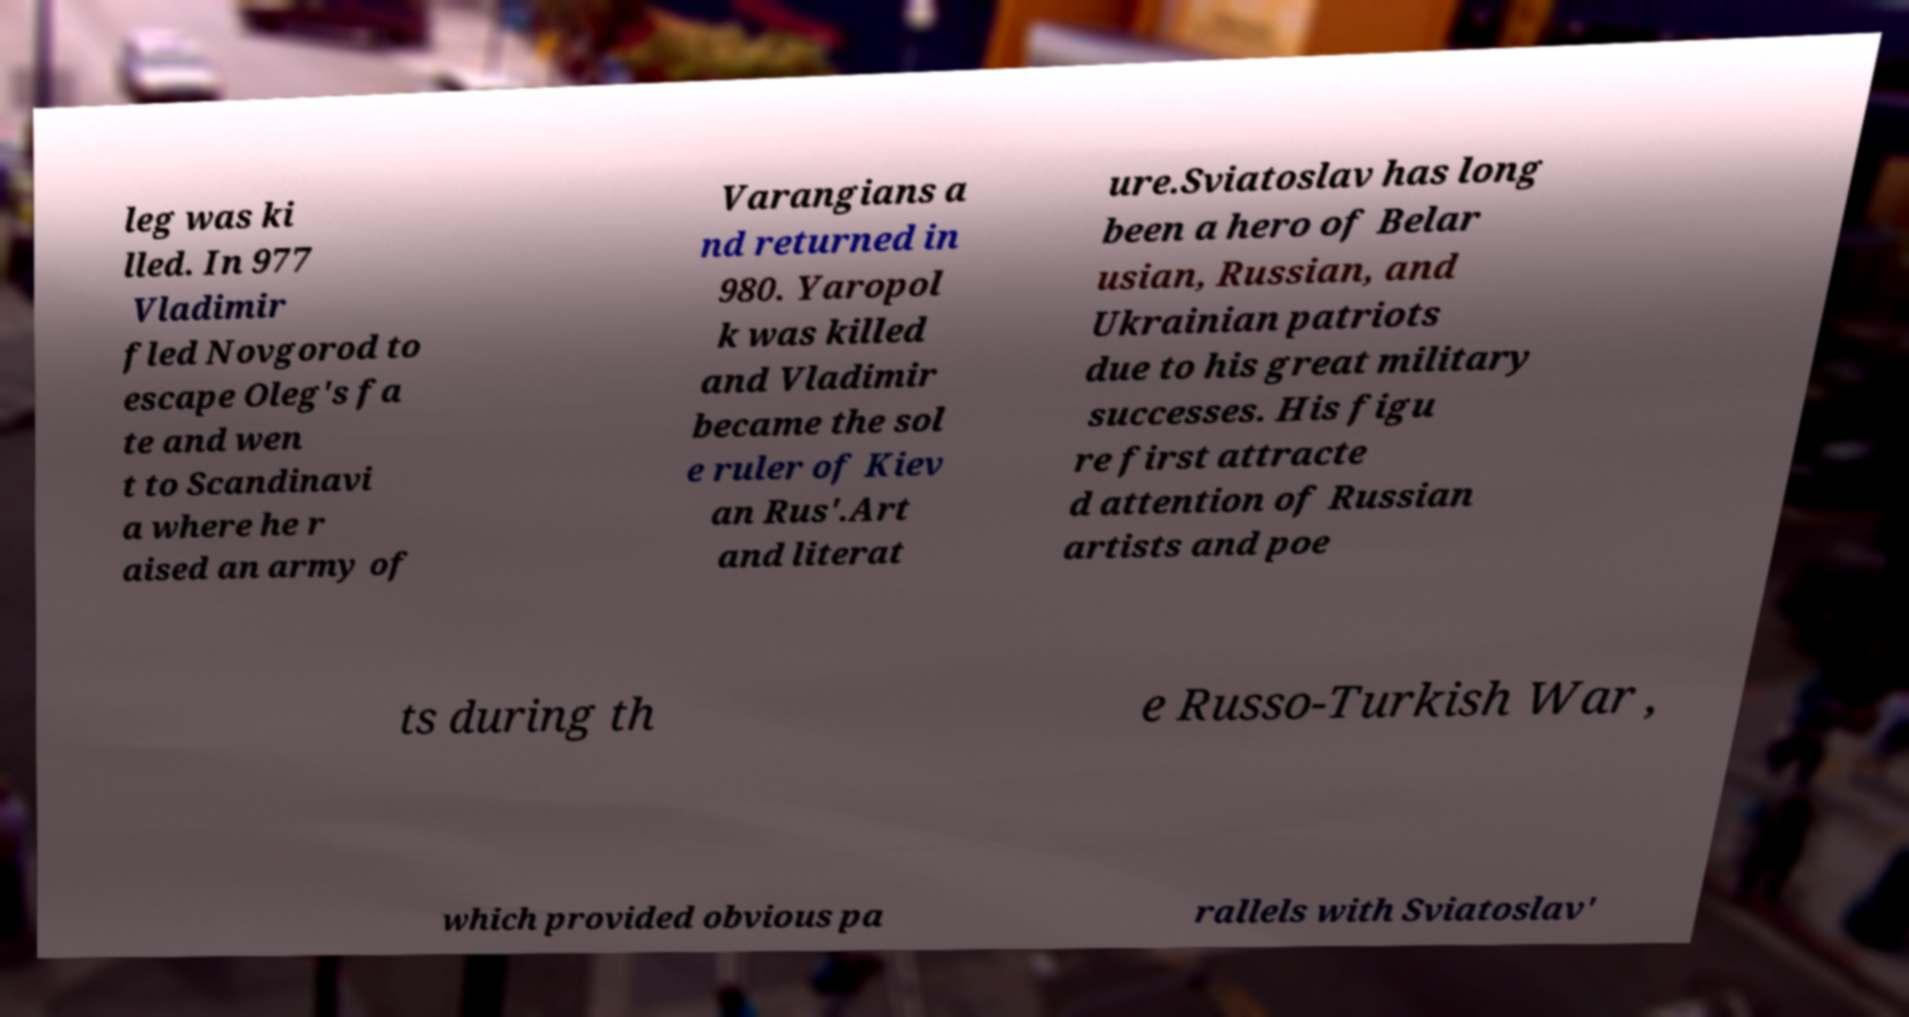I need the written content from this picture converted into text. Can you do that? leg was ki lled. In 977 Vladimir fled Novgorod to escape Oleg's fa te and wen t to Scandinavi a where he r aised an army of Varangians a nd returned in 980. Yaropol k was killed and Vladimir became the sol e ruler of Kiev an Rus'.Art and literat ure.Sviatoslav has long been a hero of Belar usian, Russian, and Ukrainian patriots due to his great military successes. His figu re first attracte d attention of Russian artists and poe ts during th e Russo-Turkish War , which provided obvious pa rallels with Sviatoslav' 